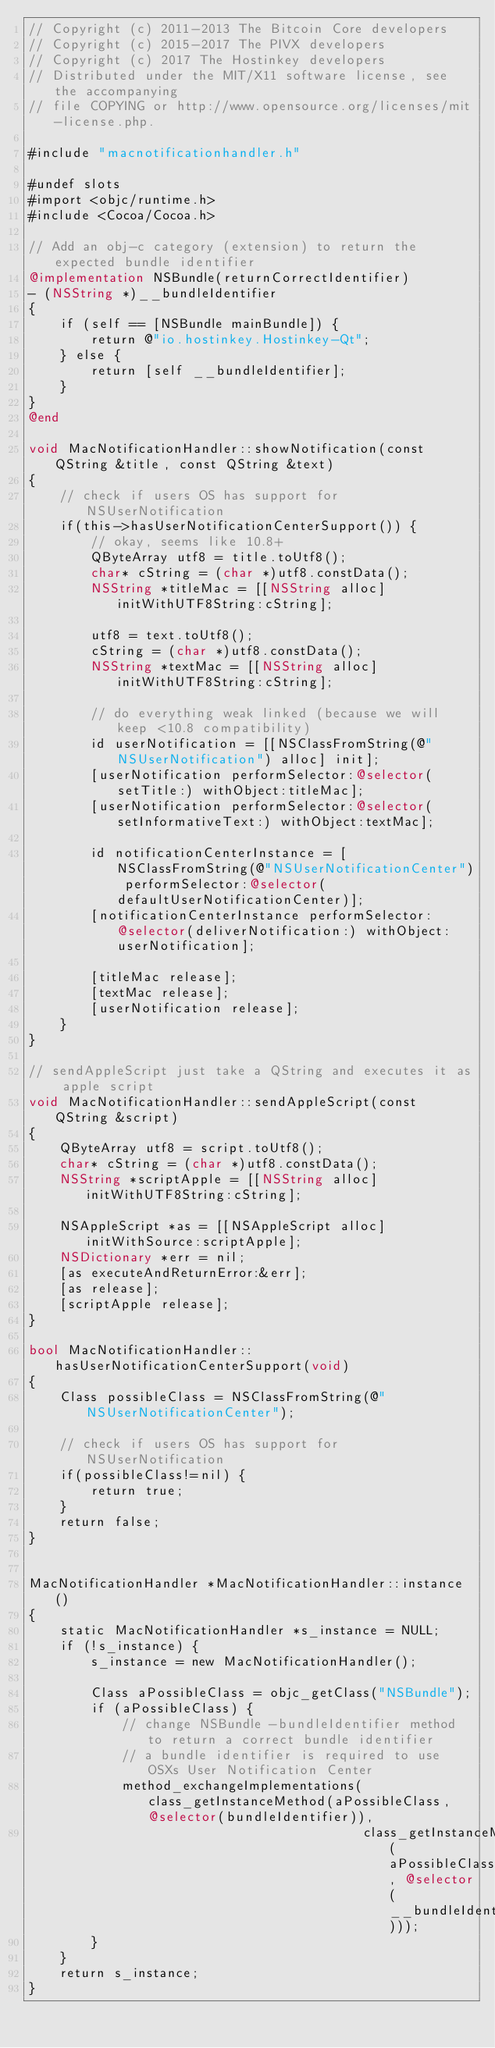<code> <loc_0><loc_0><loc_500><loc_500><_ObjectiveC_>// Copyright (c) 2011-2013 The Bitcoin Core developers
// Copyright (c) 2015-2017 The PIVX developers
// Copyright (c) 2017 The Hostinkey developers
// Distributed under the MIT/X11 software license, see the accompanying
// file COPYING or http://www.opensource.org/licenses/mit-license.php.

#include "macnotificationhandler.h"

#undef slots
#import <objc/runtime.h>
#include <Cocoa/Cocoa.h>

// Add an obj-c category (extension) to return the expected bundle identifier
@implementation NSBundle(returnCorrectIdentifier)
- (NSString *)__bundleIdentifier
{
    if (self == [NSBundle mainBundle]) {
        return @"io.hostinkey.Hostinkey-Qt";
    } else {
        return [self __bundleIdentifier];
    }
}
@end

void MacNotificationHandler::showNotification(const QString &title, const QString &text)
{
    // check if users OS has support for NSUserNotification
    if(this->hasUserNotificationCenterSupport()) {
        // okay, seems like 10.8+
        QByteArray utf8 = title.toUtf8();
        char* cString = (char *)utf8.constData();
        NSString *titleMac = [[NSString alloc] initWithUTF8String:cString];

        utf8 = text.toUtf8();
        cString = (char *)utf8.constData();
        NSString *textMac = [[NSString alloc] initWithUTF8String:cString];

        // do everything weak linked (because we will keep <10.8 compatibility)
        id userNotification = [[NSClassFromString(@"NSUserNotification") alloc] init];
        [userNotification performSelector:@selector(setTitle:) withObject:titleMac];
        [userNotification performSelector:@selector(setInformativeText:) withObject:textMac];

        id notificationCenterInstance = [NSClassFromString(@"NSUserNotificationCenter") performSelector:@selector(defaultUserNotificationCenter)];
        [notificationCenterInstance performSelector:@selector(deliverNotification:) withObject:userNotification];

        [titleMac release];
        [textMac release];
        [userNotification release];
    }
}

// sendAppleScript just take a QString and executes it as apple script
void MacNotificationHandler::sendAppleScript(const QString &script)
{
    QByteArray utf8 = script.toUtf8();
    char* cString = (char *)utf8.constData();
    NSString *scriptApple = [[NSString alloc] initWithUTF8String:cString];

    NSAppleScript *as = [[NSAppleScript alloc] initWithSource:scriptApple];
    NSDictionary *err = nil;
    [as executeAndReturnError:&err];
    [as release];
    [scriptApple release];
}

bool MacNotificationHandler::hasUserNotificationCenterSupport(void)
{
    Class possibleClass = NSClassFromString(@"NSUserNotificationCenter");

    // check if users OS has support for NSUserNotification
    if(possibleClass!=nil) {
        return true;
    }
    return false;
}


MacNotificationHandler *MacNotificationHandler::instance()
{
    static MacNotificationHandler *s_instance = NULL;
    if (!s_instance) {
        s_instance = new MacNotificationHandler();
        
        Class aPossibleClass = objc_getClass("NSBundle");
        if (aPossibleClass) {
            // change NSBundle -bundleIdentifier method to return a correct bundle identifier
            // a bundle identifier is required to use OSXs User Notification Center
            method_exchangeImplementations(class_getInstanceMethod(aPossibleClass, @selector(bundleIdentifier)),
                                           class_getInstanceMethod(aPossibleClass, @selector(__bundleIdentifier)));
        }
    }
    return s_instance;
}
</code> 